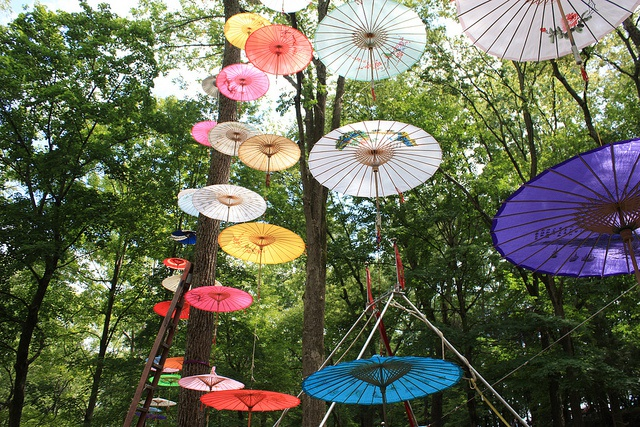Describe the objects in this image and their specific colors. I can see umbrella in lightgray, blue, darkblue, black, and navy tones, umbrella in lightgray, darkgray, gray, and tan tones, umbrella in lightgray, white, darkgray, lightblue, and tan tones, umbrella in lightgray, darkgray, and gray tones, and umbrella in lightgray, gray, black, blue, and teal tones in this image. 